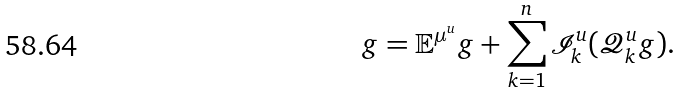<formula> <loc_0><loc_0><loc_500><loc_500>g = \mathbb { E } ^ { \mu ^ { u } } g + \sum ^ { n } _ { k = 1 } \mathcal { I } ^ { u } _ { k } ( \mathcal { Q } ^ { u } _ { k } g ) .</formula> 